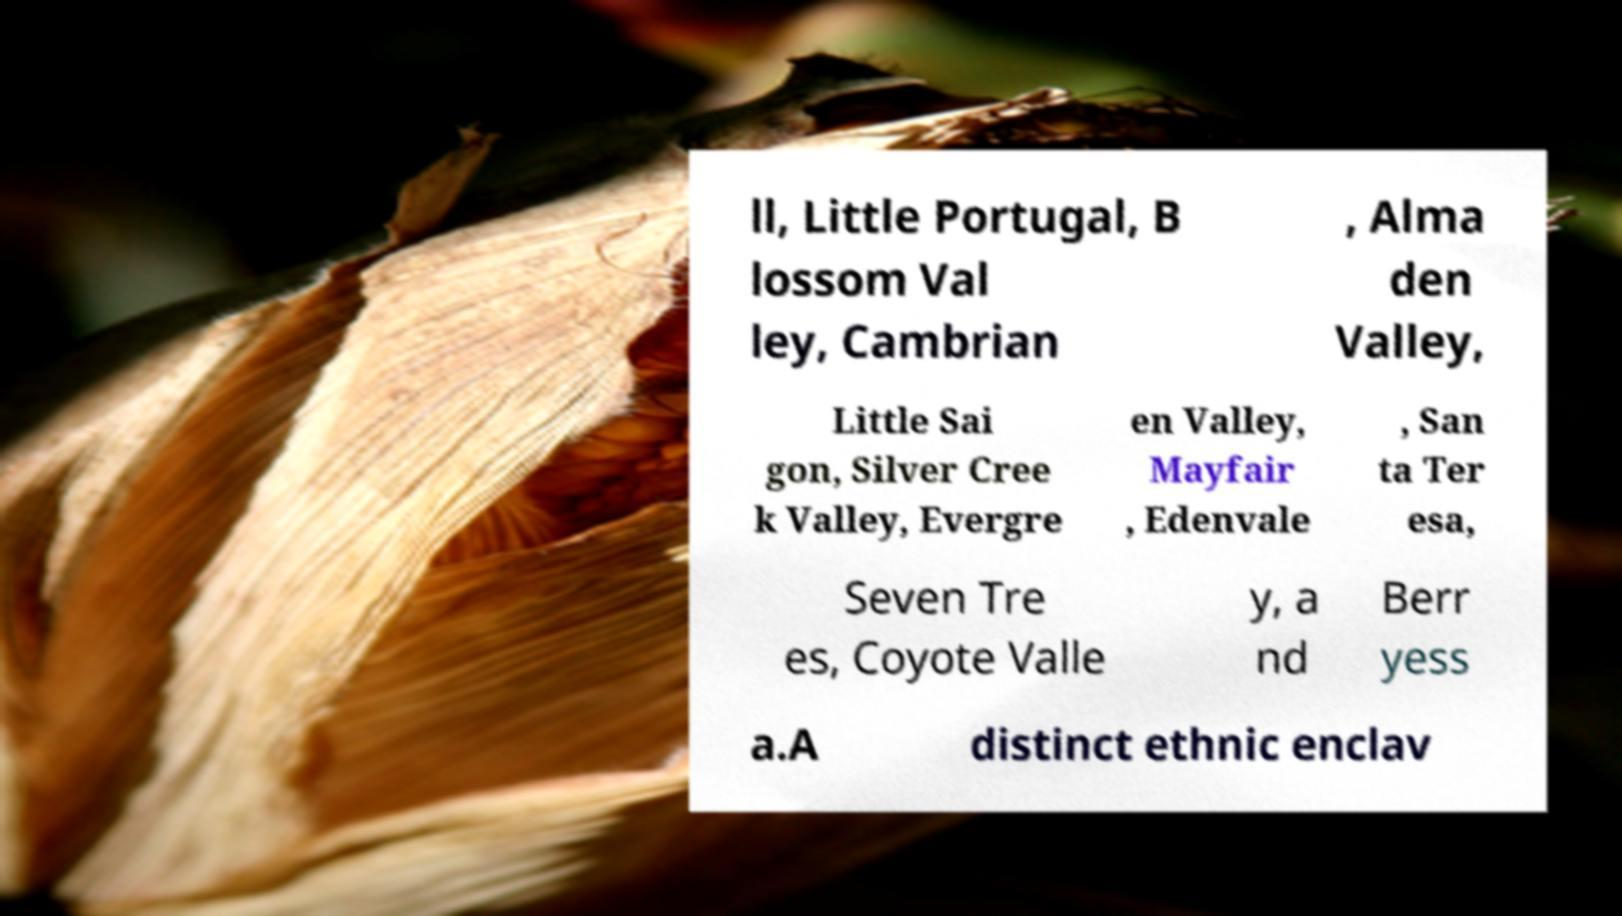Can you read and provide the text displayed in the image?This photo seems to have some interesting text. Can you extract and type it out for me? ll, Little Portugal, B lossom Val ley, Cambrian , Alma den Valley, Little Sai gon, Silver Cree k Valley, Evergre en Valley, Mayfair , Edenvale , San ta Ter esa, Seven Tre es, Coyote Valle y, a nd Berr yess a.A distinct ethnic enclav 